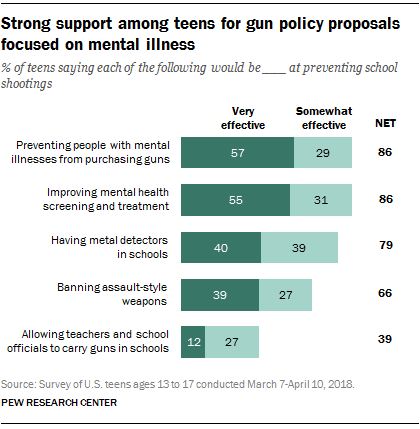List a handful of essential elements in this visual. The difference between improving mental health screening and treatment and having metal detectors in schools is 0.15. This represents value without a color segment,NET. 